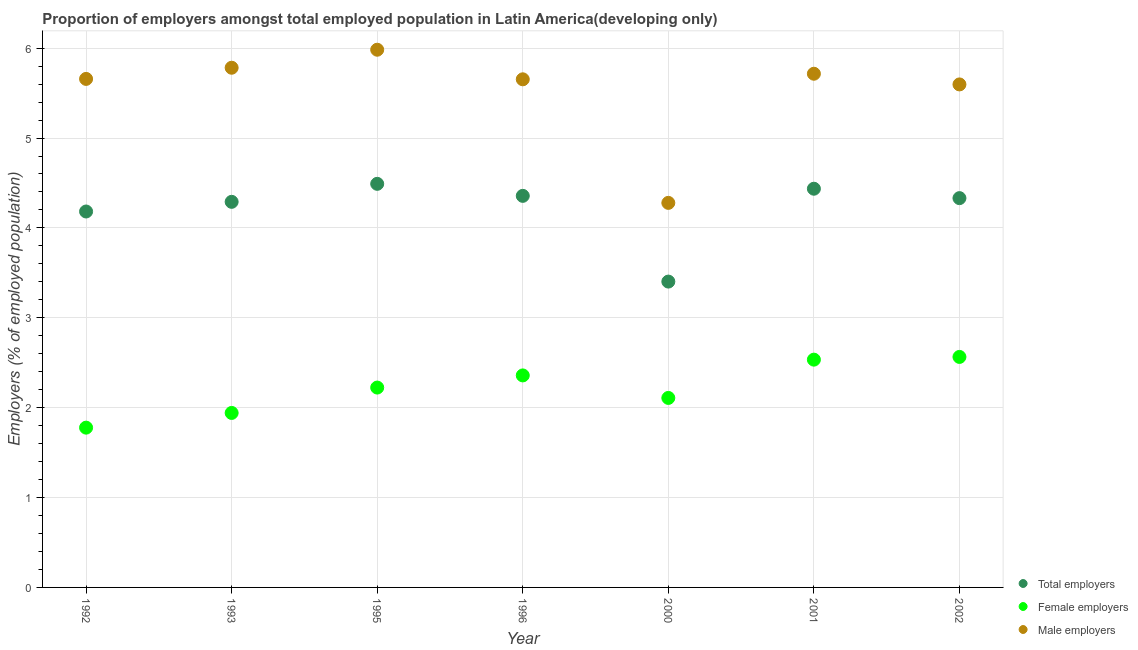How many different coloured dotlines are there?
Offer a terse response. 3. Is the number of dotlines equal to the number of legend labels?
Provide a short and direct response. Yes. What is the percentage of male employers in 1995?
Your answer should be compact. 5.98. Across all years, what is the maximum percentage of male employers?
Offer a terse response. 5.98. Across all years, what is the minimum percentage of female employers?
Provide a succinct answer. 1.78. In which year was the percentage of total employers maximum?
Provide a short and direct response. 1995. What is the total percentage of total employers in the graph?
Give a very brief answer. 29.49. What is the difference between the percentage of female employers in 1992 and that in 1995?
Make the answer very short. -0.45. What is the difference between the percentage of female employers in 2001 and the percentage of male employers in 2000?
Give a very brief answer. -1.74. What is the average percentage of female employers per year?
Offer a very short reply. 2.22. In the year 1993, what is the difference between the percentage of female employers and percentage of total employers?
Offer a terse response. -2.35. What is the ratio of the percentage of male employers in 1996 to that in 2002?
Offer a very short reply. 1.01. Is the percentage of female employers in 1995 less than that in 2000?
Provide a short and direct response. No. What is the difference between the highest and the second highest percentage of male employers?
Offer a very short reply. 0.2. What is the difference between the highest and the lowest percentage of total employers?
Offer a very short reply. 1.09. Does the percentage of male employers monotonically increase over the years?
Your answer should be very brief. No. Is the percentage of total employers strictly greater than the percentage of female employers over the years?
Make the answer very short. Yes. How many dotlines are there?
Offer a terse response. 3. How many years are there in the graph?
Provide a short and direct response. 7. Does the graph contain grids?
Give a very brief answer. Yes. Where does the legend appear in the graph?
Keep it short and to the point. Bottom right. How many legend labels are there?
Give a very brief answer. 3. How are the legend labels stacked?
Give a very brief answer. Vertical. What is the title of the graph?
Ensure brevity in your answer.  Proportion of employers amongst total employed population in Latin America(developing only). Does "Consumption Tax" appear as one of the legend labels in the graph?
Offer a terse response. No. What is the label or title of the X-axis?
Provide a short and direct response. Year. What is the label or title of the Y-axis?
Provide a short and direct response. Employers (% of employed population). What is the Employers (% of employed population) in Total employers in 1992?
Your answer should be very brief. 4.18. What is the Employers (% of employed population) of Female employers in 1992?
Keep it short and to the point. 1.78. What is the Employers (% of employed population) of Male employers in 1992?
Your answer should be compact. 5.66. What is the Employers (% of employed population) in Total employers in 1993?
Your answer should be compact. 4.29. What is the Employers (% of employed population) in Female employers in 1993?
Make the answer very short. 1.94. What is the Employers (% of employed population) of Male employers in 1993?
Ensure brevity in your answer.  5.78. What is the Employers (% of employed population) of Total employers in 1995?
Give a very brief answer. 4.49. What is the Employers (% of employed population) of Female employers in 1995?
Your answer should be very brief. 2.22. What is the Employers (% of employed population) of Male employers in 1995?
Your answer should be very brief. 5.98. What is the Employers (% of employed population) of Total employers in 1996?
Give a very brief answer. 4.36. What is the Employers (% of employed population) in Female employers in 1996?
Offer a terse response. 2.36. What is the Employers (% of employed population) of Male employers in 1996?
Your response must be concise. 5.65. What is the Employers (% of employed population) of Total employers in 2000?
Your answer should be compact. 3.4. What is the Employers (% of employed population) of Female employers in 2000?
Make the answer very short. 2.11. What is the Employers (% of employed population) of Male employers in 2000?
Make the answer very short. 4.28. What is the Employers (% of employed population) of Total employers in 2001?
Give a very brief answer. 4.44. What is the Employers (% of employed population) in Female employers in 2001?
Your response must be concise. 2.53. What is the Employers (% of employed population) of Male employers in 2001?
Make the answer very short. 5.72. What is the Employers (% of employed population) in Total employers in 2002?
Give a very brief answer. 4.33. What is the Employers (% of employed population) of Female employers in 2002?
Your response must be concise. 2.56. What is the Employers (% of employed population) in Male employers in 2002?
Your answer should be compact. 5.6. Across all years, what is the maximum Employers (% of employed population) in Total employers?
Your answer should be very brief. 4.49. Across all years, what is the maximum Employers (% of employed population) in Female employers?
Your response must be concise. 2.56. Across all years, what is the maximum Employers (% of employed population) in Male employers?
Provide a succinct answer. 5.98. Across all years, what is the minimum Employers (% of employed population) in Total employers?
Offer a terse response. 3.4. Across all years, what is the minimum Employers (% of employed population) in Female employers?
Offer a very short reply. 1.78. Across all years, what is the minimum Employers (% of employed population) in Male employers?
Your response must be concise. 4.28. What is the total Employers (% of employed population) of Total employers in the graph?
Ensure brevity in your answer.  29.49. What is the total Employers (% of employed population) of Female employers in the graph?
Offer a terse response. 15.51. What is the total Employers (% of employed population) in Male employers in the graph?
Offer a terse response. 38.67. What is the difference between the Employers (% of employed population) in Total employers in 1992 and that in 1993?
Provide a short and direct response. -0.11. What is the difference between the Employers (% of employed population) in Female employers in 1992 and that in 1993?
Give a very brief answer. -0.16. What is the difference between the Employers (% of employed population) in Male employers in 1992 and that in 1993?
Offer a terse response. -0.12. What is the difference between the Employers (% of employed population) in Total employers in 1992 and that in 1995?
Your answer should be compact. -0.31. What is the difference between the Employers (% of employed population) in Female employers in 1992 and that in 1995?
Your answer should be compact. -0.45. What is the difference between the Employers (% of employed population) of Male employers in 1992 and that in 1995?
Provide a short and direct response. -0.32. What is the difference between the Employers (% of employed population) in Total employers in 1992 and that in 1996?
Your response must be concise. -0.17. What is the difference between the Employers (% of employed population) of Female employers in 1992 and that in 1996?
Provide a succinct answer. -0.58. What is the difference between the Employers (% of employed population) of Male employers in 1992 and that in 1996?
Provide a succinct answer. 0. What is the difference between the Employers (% of employed population) of Total employers in 1992 and that in 2000?
Your answer should be compact. 0.78. What is the difference between the Employers (% of employed population) of Female employers in 1992 and that in 2000?
Your answer should be very brief. -0.33. What is the difference between the Employers (% of employed population) of Male employers in 1992 and that in 2000?
Offer a very short reply. 1.38. What is the difference between the Employers (% of employed population) in Total employers in 1992 and that in 2001?
Your response must be concise. -0.25. What is the difference between the Employers (% of employed population) of Female employers in 1992 and that in 2001?
Make the answer very short. -0.76. What is the difference between the Employers (% of employed population) of Male employers in 1992 and that in 2001?
Offer a terse response. -0.06. What is the difference between the Employers (% of employed population) of Total employers in 1992 and that in 2002?
Ensure brevity in your answer.  -0.15. What is the difference between the Employers (% of employed population) of Female employers in 1992 and that in 2002?
Provide a succinct answer. -0.79. What is the difference between the Employers (% of employed population) of Male employers in 1992 and that in 2002?
Your answer should be very brief. 0.06. What is the difference between the Employers (% of employed population) in Total employers in 1993 and that in 1995?
Your answer should be very brief. -0.2. What is the difference between the Employers (% of employed population) in Female employers in 1993 and that in 1995?
Provide a short and direct response. -0.28. What is the difference between the Employers (% of employed population) in Male employers in 1993 and that in 1995?
Ensure brevity in your answer.  -0.2. What is the difference between the Employers (% of employed population) in Total employers in 1993 and that in 1996?
Offer a very short reply. -0.07. What is the difference between the Employers (% of employed population) of Female employers in 1993 and that in 1996?
Provide a short and direct response. -0.42. What is the difference between the Employers (% of employed population) of Male employers in 1993 and that in 1996?
Offer a very short reply. 0.13. What is the difference between the Employers (% of employed population) in Total employers in 1993 and that in 2000?
Offer a very short reply. 0.89. What is the difference between the Employers (% of employed population) in Female employers in 1993 and that in 2000?
Give a very brief answer. -0.17. What is the difference between the Employers (% of employed population) in Male employers in 1993 and that in 2000?
Provide a succinct answer. 1.5. What is the difference between the Employers (% of employed population) of Total employers in 1993 and that in 2001?
Your answer should be very brief. -0.15. What is the difference between the Employers (% of employed population) of Female employers in 1993 and that in 2001?
Make the answer very short. -0.59. What is the difference between the Employers (% of employed population) in Male employers in 1993 and that in 2001?
Your answer should be very brief. 0.07. What is the difference between the Employers (% of employed population) in Total employers in 1993 and that in 2002?
Offer a very short reply. -0.04. What is the difference between the Employers (% of employed population) of Female employers in 1993 and that in 2002?
Ensure brevity in your answer.  -0.62. What is the difference between the Employers (% of employed population) of Male employers in 1993 and that in 2002?
Ensure brevity in your answer.  0.19. What is the difference between the Employers (% of employed population) in Total employers in 1995 and that in 1996?
Your answer should be compact. 0.13. What is the difference between the Employers (% of employed population) of Female employers in 1995 and that in 1996?
Your answer should be compact. -0.14. What is the difference between the Employers (% of employed population) in Male employers in 1995 and that in 1996?
Make the answer very short. 0.33. What is the difference between the Employers (% of employed population) in Total employers in 1995 and that in 2000?
Offer a very short reply. 1.09. What is the difference between the Employers (% of employed population) in Female employers in 1995 and that in 2000?
Your answer should be compact. 0.12. What is the difference between the Employers (% of employed population) in Male employers in 1995 and that in 2000?
Make the answer very short. 1.7. What is the difference between the Employers (% of employed population) in Total employers in 1995 and that in 2001?
Keep it short and to the point. 0.05. What is the difference between the Employers (% of employed population) of Female employers in 1995 and that in 2001?
Make the answer very short. -0.31. What is the difference between the Employers (% of employed population) in Male employers in 1995 and that in 2001?
Make the answer very short. 0.27. What is the difference between the Employers (% of employed population) of Total employers in 1995 and that in 2002?
Ensure brevity in your answer.  0.16. What is the difference between the Employers (% of employed population) of Female employers in 1995 and that in 2002?
Ensure brevity in your answer.  -0.34. What is the difference between the Employers (% of employed population) of Male employers in 1995 and that in 2002?
Offer a very short reply. 0.39. What is the difference between the Employers (% of employed population) of Total employers in 1996 and that in 2000?
Make the answer very short. 0.95. What is the difference between the Employers (% of employed population) of Female employers in 1996 and that in 2000?
Give a very brief answer. 0.25. What is the difference between the Employers (% of employed population) of Male employers in 1996 and that in 2000?
Your answer should be compact. 1.37. What is the difference between the Employers (% of employed population) of Total employers in 1996 and that in 2001?
Provide a succinct answer. -0.08. What is the difference between the Employers (% of employed population) in Female employers in 1996 and that in 2001?
Ensure brevity in your answer.  -0.18. What is the difference between the Employers (% of employed population) of Male employers in 1996 and that in 2001?
Keep it short and to the point. -0.06. What is the difference between the Employers (% of employed population) of Total employers in 1996 and that in 2002?
Ensure brevity in your answer.  0.03. What is the difference between the Employers (% of employed population) of Female employers in 1996 and that in 2002?
Provide a short and direct response. -0.21. What is the difference between the Employers (% of employed population) of Male employers in 1996 and that in 2002?
Ensure brevity in your answer.  0.06. What is the difference between the Employers (% of employed population) of Total employers in 2000 and that in 2001?
Offer a very short reply. -1.03. What is the difference between the Employers (% of employed population) of Female employers in 2000 and that in 2001?
Make the answer very short. -0.43. What is the difference between the Employers (% of employed population) of Male employers in 2000 and that in 2001?
Offer a terse response. -1.44. What is the difference between the Employers (% of employed population) in Total employers in 2000 and that in 2002?
Make the answer very short. -0.93. What is the difference between the Employers (% of employed population) of Female employers in 2000 and that in 2002?
Provide a short and direct response. -0.46. What is the difference between the Employers (% of employed population) in Male employers in 2000 and that in 2002?
Make the answer very short. -1.32. What is the difference between the Employers (% of employed population) in Total employers in 2001 and that in 2002?
Provide a succinct answer. 0.1. What is the difference between the Employers (% of employed population) of Female employers in 2001 and that in 2002?
Your answer should be compact. -0.03. What is the difference between the Employers (% of employed population) in Male employers in 2001 and that in 2002?
Ensure brevity in your answer.  0.12. What is the difference between the Employers (% of employed population) of Total employers in 1992 and the Employers (% of employed population) of Female employers in 1993?
Your answer should be compact. 2.24. What is the difference between the Employers (% of employed population) of Total employers in 1992 and the Employers (% of employed population) of Male employers in 1993?
Offer a terse response. -1.6. What is the difference between the Employers (% of employed population) in Female employers in 1992 and the Employers (% of employed population) in Male employers in 1993?
Your answer should be compact. -4. What is the difference between the Employers (% of employed population) of Total employers in 1992 and the Employers (% of employed population) of Female employers in 1995?
Your answer should be compact. 1.96. What is the difference between the Employers (% of employed population) in Total employers in 1992 and the Employers (% of employed population) in Male employers in 1995?
Offer a terse response. -1.8. What is the difference between the Employers (% of employed population) of Female employers in 1992 and the Employers (% of employed population) of Male employers in 1995?
Offer a terse response. -4.2. What is the difference between the Employers (% of employed population) of Total employers in 1992 and the Employers (% of employed population) of Female employers in 1996?
Offer a terse response. 1.82. What is the difference between the Employers (% of employed population) in Total employers in 1992 and the Employers (% of employed population) in Male employers in 1996?
Give a very brief answer. -1.47. What is the difference between the Employers (% of employed population) in Female employers in 1992 and the Employers (% of employed population) in Male employers in 1996?
Ensure brevity in your answer.  -3.88. What is the difference between the Employers (% of employed population) in Total employers in 1992 and the Employers (% of employed population) in Female employers in 2000?
Make the answer very short. 2.07. What is the difference between the Employers (% of employed population) of Total employers in 1992 and the Employers (% of employed population) of Male employers in 2000?
Ensure brevity in your answer.  -0.1. What is the difference between the Employers (% of employed population) in Female employers in 1992 and the Employers (% of employed population) in Male employers in 2000?
Your response must be concise. -2.5. What is the difference between the Employers (% of employed population) in Total employers in 1992 and the Employers (% of employed population) in Female employers in 2001?
Offer a terse response. 1.65. What is the difference between the Employers (% of employed population) in Total employers in 1992 and the Employers (% of employed population) in Male employers in 2001?
Keep it short and to the point. -1.53. What is the difference between the Employers (% of employed population) of Female employers in 1992 and the Employers (% of employed population) of Male employers in 2001?
Your answer should be compact. -3.94. What is the difference between the Employers (% of employed population) in Total employers in 1992 and the Employers (% of employed population) in Female employers in 2002?
Offer a very short reply. 1.62. What is the difference between the Employers (% of employed population) of Total employers in 1992 and the Employers (% of employed population) of Male employers in 2002?
Offer a very short reply. -1.41. What is the difference between the Employers (% of employed population) of Female employers in 1992 and the Employers (% of employed population) of Male employers in 2002?
Ensure brevity in your answer.  -3.82. What is the difference between the Employers (% of employed population) of Total employers in 1993 and the Employers (% of employed population) of Female employers in 1995?
Your answer should be very brief. 2.07. What is the difference between the Employers (% of employed population) of Total employers in 1993 and the Employers (% of employed population) of Male employers in 1995?
Ensure brevity in your answer.  -1.69. What is the difference between the Employers (% of employed population) in Female employers in 1993 and the Employers (% of employed population) in Male employers in 1995?
Your answer should be compact. -4.04. What is the difference between the Employers (% of employed population) in Total employers in 1993 and the Employers (% of employed population) in Female employers in 1996?
Make the answer very short. 1.93. What is the difference between the Employers (% of employed population) in Total employers in 1993 and the Employers (% of employed population) in Male employers in 1996?
Give a very brief answer. -1.36. What is the difference between the Employers (% of employed population) of Female employers in 1993 and the Employers (% of employed population) of Male employers in 1996?
Offer a terse response. -3.71. What is the difference between the Employers (% of employed population) of Total employers in 1993 and the Employers (% of employed population) of Female employers in 2000?
Your response must be concise. 2.18. What is the difference between the Employers (% of employed population) of Total employers in 1993 and the Employers (% of employed population) of Male employers in 2000?
Your response must be concise. 0.01. What is the difference between the Employers (% of employed population) in Female employers in 1993 and the Employers (% of employed population) in Male employers in 2000?
Offer a very short reply. -2.34. What is the difference between the Employers (% of employed population) of Total employers in 1993 and the Employers (% of employed population) of Female employers in 2001?
Your answer should be compact. 1.76. What is the difference between the Employers (% of employed population) in Total employers in 1993 and the Employers (% of employed population) in Male employers in 2001?
Your response must be concise. -1.43. What is the difference between the Employers (% of employed population) of Female employers in 1993 and the Employers (% of employed population) of Male employers in 2001?
Give a very brief answer. -3.77. What is the difference between the Employers (% of employed population) of Total employers in 1993 and the Employers (% of employed population) of Female employers in 2002?
Offer a terse response. 1.73. What is the difference between the Employers (% of employed population) in Total employers in 1993 and the Employers (% of employed population) in Male employers in 2002?
Provide a short and direct response. -1.31. What is the difference between the Employers (% of employed population) of Female employers in 1993 and the Employers (% of employed population) of Male employers in 2002?
Offer a terse response. -3.66. What is the difference between the Employers (% of employed population) in Total employers in 1995 and the Employers (% of employed population) in Female employers in 1996?
Offer a very short reply. 2.13. What is the difference between the Employers (% of employed population) of Total employers in 1995 and the Employers (% of employed population) of Male employers in 1996?
Keep it short and to the point. -1.16. What is the difference between the Employers (% of employed population) of Female employers in 1995 and the Employers (% of employed population) of Male employers in 1996?
Offer a terse response. -3.43. What is the difference between the Employers (% of employed population) of Total employers in 1995 and the Employers (% of employed population) of Female employers in 2000?
Ensure brevity in your answer.  2.38. What is the difference between the Employers (% of employed population) in Total employers in 1995 and the Employers (% of employed population) in Male employers in 2000?
Make the answer very short. 0.21. What is the difference between the Employers (% of employed population) of Female employers in 1995 and the Employers (% of employed population) of Male employers in 2000?
Your response must be concise. -2.05. What is the difference between the Employers (% of employed population) in Total employers in 1995 and the Employers (% of employed population) in Female employers in 2001?
Your response must be concise. 1.96. What is the difference between the Employers (% of employed population) of Total employers in 1995 and the Employers (% of employed population) of Male employers in 2001?
Your answer should be compact. -1.22. What is the difference between the Employers (% of employed population) in Female employers in 1995 and the Employers (% of employed population) in Male employers in 2001?
Your response must be concise. -3.49. What is the difference between the Employers (% of employed population) in Total employers in 1995 and the Employers (% of employed population) in Female employers in 2002?
Give a very brief answer. 1.93. What is the difference between the Employers (% of employed population) of Total employers in 1995 and the Employers (% of employed population) of Male employers in 2002?
Keep it short and to the point. -1.11. What is the difference between the Employers (% of employed population) in Female employers in 1995 and the Employers (% of employed population) in Male employers in 2002?
Provide a short and direct response. -3.37. What is the difference between the Employers (% of employed population) in Total employers in 1996 and the Employers (% of employed population) in Female employers in 2000?
Offer a very short reply. 2.25. What is the difference between the Employers (% of employed population) in Total employers in 1996 and the Employers (% of employed population) in Male employers in 2000?
Your answer should be compact. 0.08. What is the difference between the Employers (% of employed population) in Female employers in 1996 and the Employers (% of employed population) in Male employers in 2000?
Offer a very short reply. -1.92. What is the difference between the Employers (% of employed population) of Total employers in 1996 and the Employers (% of employed population) of Female employers in 2001?
Ensure brevity in your answer.  1.82. What is the difference between the Employers (% of employed population) in Total employers in 1996 and the Employers (% of employed population) in Male employers in 2001?
Give a very brief answer. -1.36. What is the difference between the Employers (% of employed population) of Female employers in 1996 and the Employers (% of employed population) of Male employers in 2001?
Ensure brevity in your answer.  -3.36. What is the difference between the Employers (% of employed population) of Total employers in 1996 and the Employers (% of employed population) of Female employers in 2002?
Ensure brevity in your answer.  1.79. What is the difference between the Employers (% of employed population) in Total employers in 1996 and the Employers (% of employed population) in Male employers in 2002?
Provide a succinct answer. -1.24. What is the difference between the Employers (% of employed population) of Female employers in 1996 and the Employers (% of employed population) of Male employers in 2002?
Ensure brevity in your answer.  -3.24. What is the difference between the Employers (% of employed population) of Total employers in 2000 and the Employers (% of employed population) of Female employers in 2001?
Your response must be concise. 0.87. What is the difference between the Employers (% of employed population) of Total employers in 2000 and the Employers (% of employed population) of Male employers in 2001?
Your response must be concise. -2.31. What is the difference between the Employers (% of employed population) of Female employers in 2000 and the Employers (% of employed population) of Male employers in 2001?
Your answer should be compact. -3.61. What is the difference between the Employers (% of employed population) of Total employers in 2000 and the Employers (% of employed population) of Female employers in 2002?
Offer a very short reply. 0.84. What is the difference between the Employers (% of employed population) of Total employers in 2000 and the Employers (% of employed population) of Male employers in 2002?
Your answer should be very brief. -2.19. What is the difference between the Employers (% of employed population) in Female employers in 2000 and the Employers (% of employed population) in Male employers in 2002?
Your response must be concise. -3.49. What is the difference between the Employers (% of employed population) of Total employers in 2001 and the Employers (% of employed population) of Female employers in 2002?
Your answer should be compact. 1.87. What is the difference between the Employers (% of employed population) in Total employers in 2001 and the Employers (% of employed population) in Male employers in 2002?
Ensure brevity in your answer.  -1.16. What is the difference between the Employers (% of employed population) in Female employers in 2001 and the Employers (% of employed population) in Male employers in 2002?
Ensure brevity in your answer.  -3.06. What is the average Employers (% of employed population) of Total employers per year?
Your answer should be compact. 4.21. What is the average Employers (% of employed population) in Female employers per year?
Your answer should be very brief. 2.22. What is the average Employers (% of employed population) in Male employers per year?
Your answer should be very brief. 5.52. In the year 1992, what is the difference between the Employers (% of employed population) of Total employers and Employers (% of employed population) of Female employers?
Your response must be concise. 2.4. In the year 1992, what is the difference between the Employers (% of employed population) of Total employers and Employers (% of employed population) of Male employers?
Your answer should be very brief. -1.48. In the year 1992, what is the difference between the Employers (% of employed population) of Female employers and Employers (% of employed population) of Male employers?
Offer a terse response. -3.88. In the year 1993, what is the difference between the Employers (% of employed population) of Total employers and Employers (% of employed population) of Female employers?
Keep it short and to the point. 2.35. In the year 1993, what is the difference between the Employers (% of employed population) in Total employers and Employers (% of employed population) in Male employers?
Your response must be concise. -1.49. In the year 1993, what is the difference between the Employers (% of employed population) in Female employers and Employers (% of employed population) in Male employers?
Ensure brevity in your answer.  -3.84. In the year 1995, what is the difference between the Employers (% of employed population) in Total employers and Employers (% of employed population) in Female employers?
Offer a very short reply. 2.27. In the year 1995, what is the difference between the Employers (% of employed population) in Total employers and Employers (% of employed population) in Male employers?
Your answer should be compact. -1.49. In the year 1995, what is the difference between the Employers (% of employed population) in Female employers and Employers (% of employed population) in Male employers?
Offer a terse response. -3.76. In the year 1996, what is the difference between the Employers (% of employed population) in Total employers and Employers (% of employed population) in Female employers?
Offer a terse response. 2. In the year 1996, what is the difference between the Employers (% of employed population) in Total employers and Employers (% of employed population) in Male employers?
Your answer should be compact. -1.3. In the year 1996, what is the difference between the Employers (% of employed population) in Female employers and Employers (% of employed population) in Male employers?
Offer a very short reply. -3.29. In the year 2000, what is the difference between the Employers (% of employed population) in Total employers and Employers (% of employed population) in Female employers?
Give a very brief answer. 1.29. In the year 2000, what is the difference between the Employers (% of employed population) of Total employers and Employers (% of employed population) of Male employers?
Your response must be concise. -0.88. In the year 2000, what is the difference between the Employers (% of employed population) of Female employers and Employers (% of employed population) of Male employers?
Keep it short and to the point. -2.17. In the year 2001, what is the difference between the Employers (% of employed population) in Total employers and Employers (% of employed population) in Female employers?
Ensure brevity in your answer.  1.9. In the year 2001, what is the difference between the Employers (% of employed population) of Total employers and Employers (% of employed population) of Male employers?
Keep it short and to the point. -1.28. In the year 2001, what is the difference between the Employers (% of employed population) in Female employers and Employers (% of employed population) in Male employers?
Your response must be concise. -3.18. In the year 2002, what is the difference between the Employers (% of employed population) of Total employers and Employers (% of employed population) of Female employers?
Provide a short and direct response. 1.77. In the year 2002, what is the difference between the Employers (% of employed population) in Total employers and Employers (% of employed population) in Male employers?
Make the answer very short. -1.27. In the year 2002, what is the difference between the Employers (% of employed population) of Female employers and Employers (% of employed population) of Male employers?
Keep it short and to the point. -3.03. What is the ratio of the Employers (% of employed population) in Total employers in 1992 to that in 1993?
Offer a terse response. 0.97. What is the ratio of the Employers (% of employed population) of Female employers in 1992 to that in 1993?
Keep it short and to the point. 0.92. What is the ratio of the Employers (% of employed population) of Male employers in 1992 to that in 1993?
Make the answer very short. 0.98. What is the ratio of the Employers (% of employed population) of Total employers in 1992 to that in 1995?
Offer a terse response. 0.93. What is the ratio of the Employers (% of employed population) of Female employers in 1992 to that in 1995?
Provide a succinct answer. 0.8. What is the ratio of the Employers (% of employed population) in Male employers in 1992 to that in 1995?
Keep it short and to the point. 0.95. What is the ratio of the Employers (% of employed population) in Total employers in 1992 to that in 1996?
Provide a short and direct response. 0.96. What is the ratio of the Employers (% of employed population) of Female employers in 1992 to that in 1996?
Your response must be concise. 0.75. What is the ratio of the Employers (% of employed population) of Total employers in 1992 to that in 2000?
Make the answer very short. 1.23. What is the ratio of the Employers (% of employed population) in Female employers in 1992 to that in 2000?
Your answer should be very brief. 0.84. What is the ratio of the Employers (% of employed population) in Male employers in 1992 to that in 2000?
Provide a succinct answer. 1.32. What is the ratio of the Employers (% of employed population) of Total employers in 1992 to that in 2001?
Ensure brevity in your answer.  0.94. What is the ratio of the Employers (% of employed population) in Female employers in 1992 to that in 2001?
Give a very brief answer. 0.7. What is the ratio of the Employers (% of employed population) of Total employers in 1992 to that in 2002?
Offer a terse response. 0.97. What is the ratio of the Employers (% of employed population) of Female employers in 1992 to that in 2002?
Ensure brevity in your answer.  0.69. What is the ratio of the Employers (% of employed population) in Male employers in 1992 to that in 2002?
Your answer should be very brief. 1.01. What is the ratio of the Employers (% of employed population) in Total employers in 1993 to that in 1995?
Make the answer very short. 0.96. What is the ratio of the Employers (% of employed population) of Female employers in 1993 to that in 1995?
Your answer should be compact. 0.87. What is the ratio of the Employers (% of employed population) of Male employers in 1993 to that in 1995?
Make the answer very short. 0.97. What is the ratio of the Employers (% of employed population) in Total employers in 1993 to that in 1996?
Your response must be concise. 0.98. What is the ratio of the Employers (% of employed population) in Female employers in 1993 to that in 1996?
Offer a very short reply. 0.82. What is the ratio of the Employers (% of employed population) in Male employers in 1993 to that in 1996?
Offer a terse response. 1.02. What is the ratio of the Employers (% of employed population) of Total employers in 1993 to that in 2000?
Your answer should be compact. 1.26. What is the ratio of the Employers (% of employed population) in Female employers in 1993 to that in 2000?
Make the answer very short. 0.92. What is the ratio of the Employers (% of employed population) of Male employers in 1993 to that in 2000?
Ensure brevity in your answer.  1.35. What is the ratio of the Employers (% of employed population) of Total employers in 1993 to that in 2001?
Keep it short and to the point. 0.97. What is the ratio of the Employers (% of employed population) in Female employers in 1993 to that in 2001?
Provide a short and direct response. 0.77. What is the ratio of the Employers (% of employed population) in Male employers in 1993 to that in 2001?
Offer a terse response. 1.01. What is the ratio of the Employers (% of employed population) of Female employers in 1993 to that in 2002?
Offer a terse response. 0.76. What is the ratio of the Employers (% of employed population) of Male employers in 1993 to that in 2002?
Your answer should be compact. 1.03. What is the ratio of the Employers (% of employed population) in Total employers in 1995 to that in 1996?
Offer a very short reply. 1.03. What is the ratio of the Employers (% of employed population) of Female employers in 1995 to that in 1996?
Make the answer very short. 0.94. What is the ratio of the Employers (% of employed population) of Male employers in 1995 to that in 1996?
Your response must be concise. 1.06. What is the ratio of the Employers (% of employed population) of Total employers in 1995 to that in 2000?
Your response must be concise. 1.32. What is the ratio of the Employers (% of employed population) of Female employers in 1995 to that in 2000?
Offer a very short reply. 1.05. What is the ratio of the Employers (% of employed population) in Male employers in 1995 to that in 2000?
Your answer should be very brief. 1.4. What is the ratio of the Employers (% of employed population) in Total employers in 1995 to that in 2001?
Ensure brevity in your answer.  1.01. What is the ratio of the Employers (% of employed population) of Female employers in 1995 to that in 2001?
Your answer should be compact. 0.88. What is the ratio of the Employers (% of employed population) in Male employers in 1995 to that in 2001?
Your answer should be very brief. 1.05. What is the ratio of the Employers (% of employed population) in Total employers in 1995 to that in 2002?
Ensure brevity in your answer.  1.04. What is the ratio of the Employers (% of employed population) of Female employers in 1995 to that in 2002?
Your answer should be compact. 0.87. What is the ratio of the Employers (% of employed population) of Male employers in 1995 to that in 2002?
Your response must be concise. 1.07. What is the ratio of the Employers (% of employed population) in Total employers in 1996 to that in 2000?
Provide a short and direct response. 1.28. What is the ratio of the Employers (% of employed population) of Female employers in 1996 to that in 2000?
Offer a very short reply. 1.12. What is the ratio of the Employers (% of employed population) of Male employers in 1996 to that in 2000?
Keep it short and to the point. 1.32. What is the ratio of the Employers (% of employed population) of Total employers in 1996 to that in 2001?
Your response must be concise. 0.98. What is the ratio of the Employers (% of employed population) in Female employers in 1996 to that in 2001?
Provide a succinct answer. 0.93. What is the ratio of the Employers (% of employed population) in Female employers in 1996 to that in 2002?
Provide a succinct answer. 0.92. What is the ratio of the Employers (% of employed population) in Male employers in 1996 to that in 2002?
Your response must be concise. 1.01. What is the ratio of the Employers (% of employed population) of Total employers in 2000 to that in 2001?
Your response must be concise. 0.77. What is the ratio of the Employers (% of employed population) in Female employers in 2000 to that in 2001?
Offer a terse response. 0.83. What is the ratio of the Employers (% of employed population) in Male employers in 2000 to that in 2001?
Keep it short and to the point. 0.75. What is the ratio of the Employers (% of employed population) in Total employers in 2000 to that in 2002?
Keep it short and to the point. 0.79. What is the ratio of the Employers (% of employed population) of Female employers in 2000 to that in 2002?
Give a very brief answer. 0.82. What is the ratio of the Employers (% of employed population) in Male employers in 2000 to that in 2002?
Provide a short and direct response. 0.76. What is the ratio of the Employers (% of employed population) in Total employers in 2001 to that in 2002?
Give a very brief answer. 1.02. What is the ratio of the Employers (% of employed population) in Male employers in 2001 to that in 2002?
Provide a succinct answer. 1.02. What is the difference between the highest and the second highest Employers (% of employed population) in Total employers?
Give a very brief answer. 0.05. What is the difference between the highest and the second highest Employers (% of employed population) of Female employers?
Ensure brevity in your answer.  0.03. What is the difference between the highest and the second highest Employers (% of employed population) of Male employers?
Your answer should be very brief. 0.2. What is the difference between the highest and the lowest Employers (% of employed population) in Total employers?
Ensure brevity in your answer.  1.09. What is the difference between the highest and the lowest Employers (% of employed population) of Female employers?
Give a very brief answer. 0.79. What is the difference between the highest and the lowest Employers (% of employed population) in Male employers?
Your answer should be very brief. 1.7. 